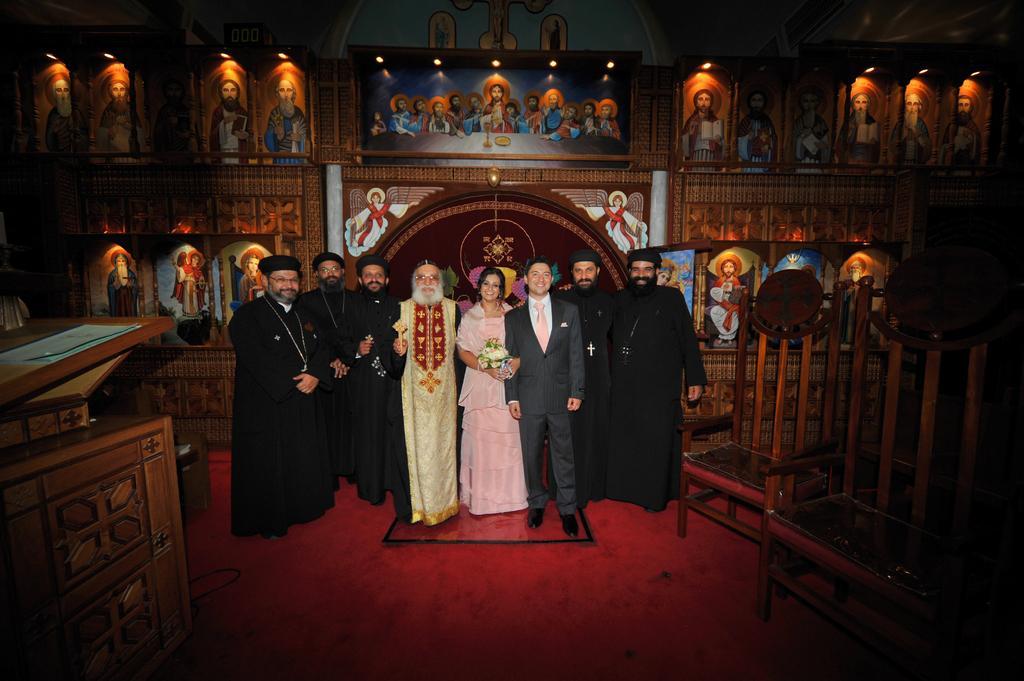Could you give a brief overview of what you see in this image? In this image there are a few people standing with a smile on their face. On the right side there are chairs. On the left side there is a table. In the background there are few photo frames of the Jesus attached to the wall with lights. 